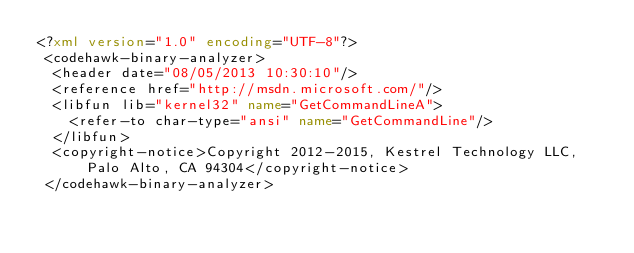Convert code to text. <code><loc_0><loc_0><loc_500><loc_500><_XML_><?xml version="1.0" encoding="UTF-8"?>
 <codehawk-binary-analyzer>
  <header date="08/05/2013 10:30:10"/>
  <reference href="http://msdn.microsoft.com/"/>
  <libfun lib="kernel32" name="GetCommandLineA">
    <refer-to char-type="ansi" name="GetCommandLine"/>
  </libfun>
  <copyright-notice>Copyright 2012-2015, Kestrel Technology LLC, Palo Alto, CA 94304</copyright-notice>
 </codehawk-binary-analyzer>
</code> 